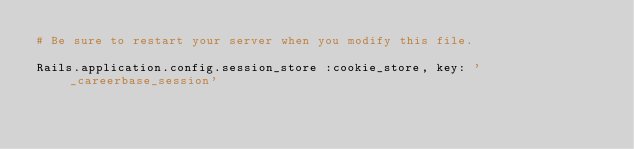Convert code to text. <code><loc_0><loc_0><loc_500><loc_500><_Ruby_># Be sure to restart your server when you modify this file.

Rails.application.config.session_store :cookie_store, key: '_careerbase_session'
</code> 